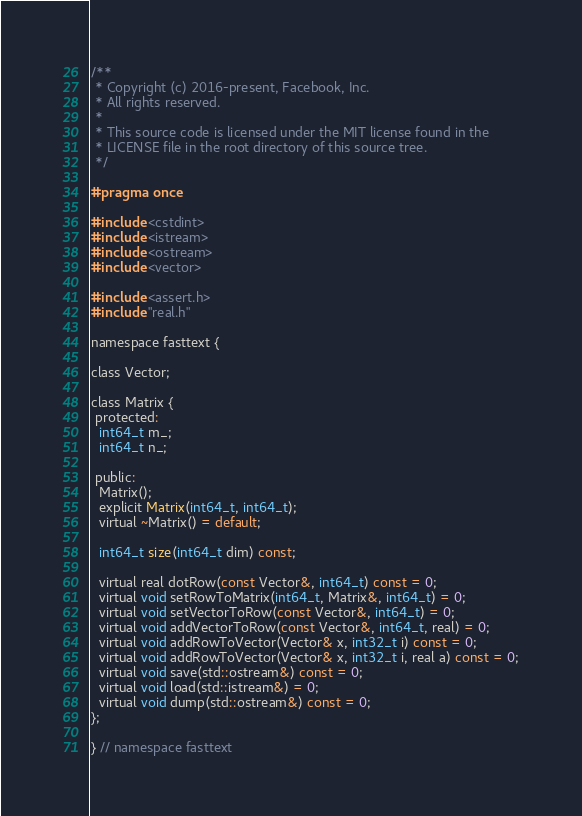Convert code to text. <code><loc_0><loc_0><loc_500><loc_500><_C_>/**
 * Copyright (c) 2016-present, Facebook, Inc.
 * All rights reserved.
 *
 * This source code is licensed under the MIT license found in the
 * LICENSE file in the root directory of this source tree.
 */

#pragma once

#include <cstdint>
#include <istream>
#include <ostream>
#include <vector>

#include <assert.h>
#include "real.h"

namespace fasttext {

class Vector;

class Matrix {
 protected:
  int64_t m_;
  int64_t n_;

 public:
  Matrix();
  explicit Matrix(int64_t, int64_t);
  virtual ~Matrix() = default;

  int64_t size(int64_t dim) const;

  virtual real dotRow(const Vector&, int64_t) const = 0;
  virtual void setRowToMatrix(int64_t, Matrix&, int64_t) = 0;
  virtual void setVectorToRow(const Vector&, int64_t) = 0;
  virtual void addVectorToRow(const Vector&, int64_t, real) = 0;
  virtual void addRowToVector(Vector& x, int32_t i) const = 0;
  virtual void addRowToVector(Vector& x, int32_t i, real a) const = 0;
  virtual void save(std::ostream&) const = 0;
  virtual void load(std::istream&) = 0;
  virtual void dump(std::ostream&) const = 0;
};

} // namespace fasttext
</code> 